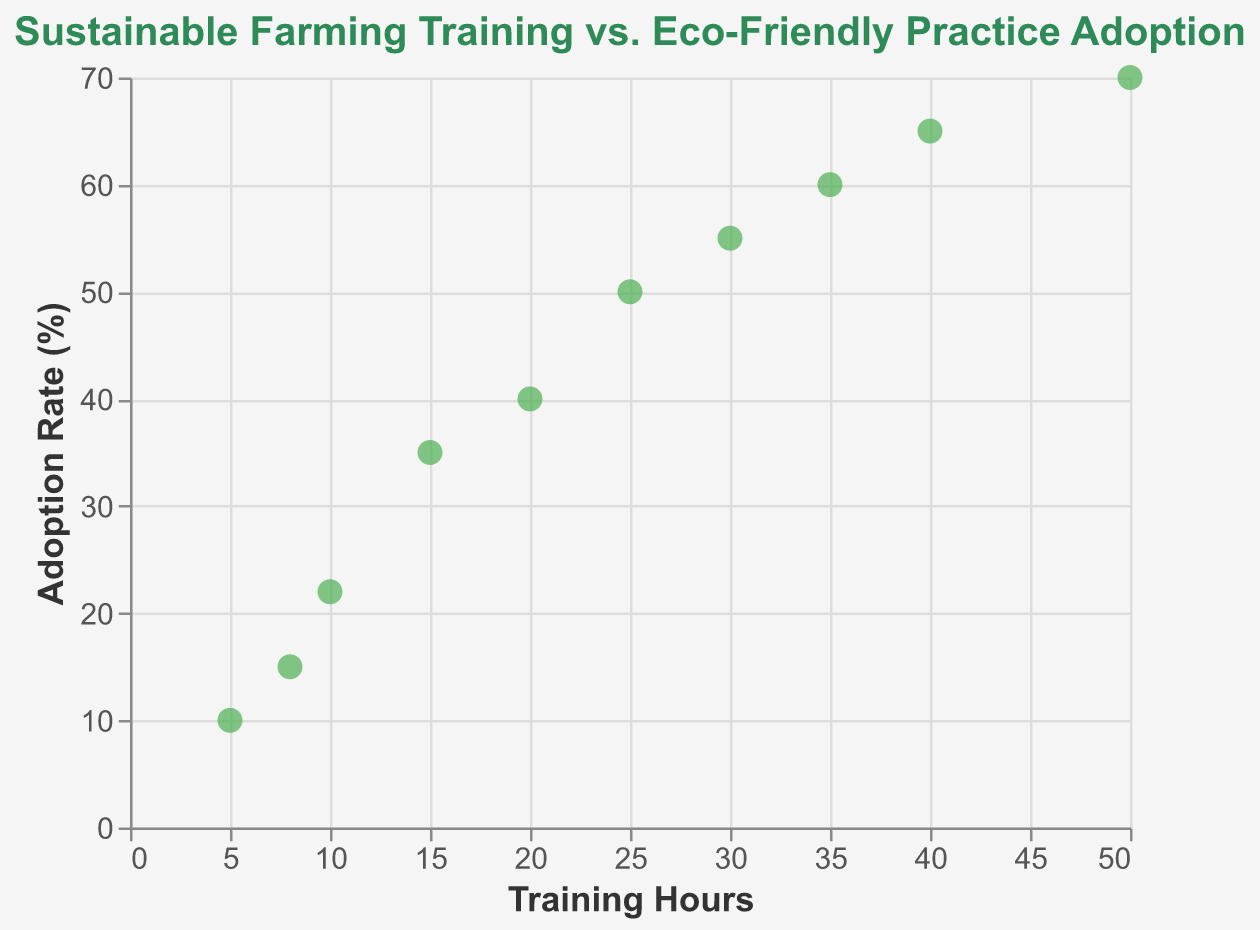What is the title of the plot? The plot title is typically displayed at the top of the chart and gives an overview of what the plot represents. Here, it indicates that the plot shows the relationship between Sustainable Farming Training hours and the Adoption Rate of Eco-Friendly Practices.
Answer: Sustainable Farming Training vs. Eco-Friendly Practice Adoption What are the labels on the x-axis and y-axis? The x-axis and y-axis labels describe the variables being plotted. On the x-axis, we have 'Training Hours,' and on the y-axis, we have 'Adoption Rate (%).'
Answer: Training Hours, Adoption Rate (%) How many data points are there in the plot? Each point on the scatter plot represents a data entry. Counting all the points, we find a total of 10 data points.
Answer: 10 Which data point has the highest adoption rate, and what are its corresponding training hours? To find the data point with the highest adoption rate, we look for the point with the highest y-value. Here, the highest adoption rate is 70%, which corresponds to 50 training hours.
Answer: 70%, 50 hours Describe the relationship between training hours and adoption rate. The scatter plot reveals a positive relationship where the adoption rate of eco-friendly practices increases as training hours increase. This can be seen through the upward trend in the points on the plot.
Answer: Positive relationship What is the adoption rate when training hours are 25? Look for the point where 'Hours of Training' is 25 and identify its corresponding adoption rate on the y-axis. The adoption rate is 50%.
Answer: 50% What is the difference in the adoption rate between 10 and 40 training hours? Identify the adoption rates for 10 and 40 training hours, which are 22% and 65%, respectively. Subtract the smaller value from the larger one: 65% - 22% = 43%.
Answer: 43% What is the average adoption rate for training hours of 10, 20, and 30? First, find the adoption rates for these training hours: 22%, 40%, and 55%, respectively. Then, calculate the average by summing these values and dividing by the number of data points: (22 + 40 + 55) / 3 = 117 / 3 = 39%.
Answer: 39% Which data point shows the steepest increase in adoption rate compared to the preceding point? We need to calculate the rate of change between consecutive training hours. The steepest increase can be found between 10 and 15 training hours, where the adoption rate goes from 22% to 35%, an increase of 13%. This is the largest single increase among consecutive points.
Answer: 15 training hours, 35% adoption rate Is there a plateau observed in the relationship between training hours and adoption rate, and if so, at what range? Observing the interval where adoption rate increases relatively slowly compared to previous intervals will help identify a plateau. The plateau appears around 30 to 40 training hours, where the adoption rate increases from 55% to 65%.
Answer: 30 to 40 training hours 